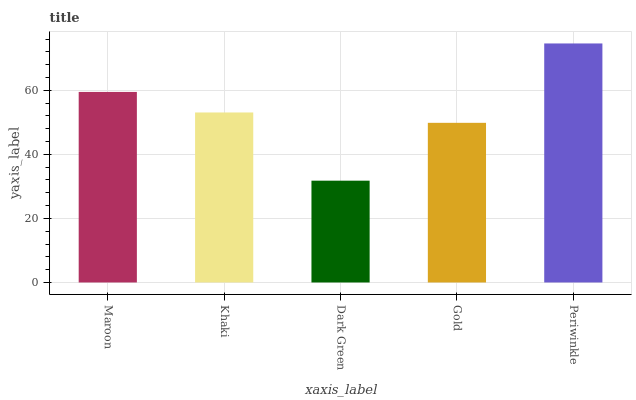Is Dark Green the minimum?
Answer yes or no. Yes. Is Periwinkle the maximum?
Answer yes or no. Yes. Is Khaki the minimum?
Answer yes or no. No. Is Khaki the maximum?
Answer yes or no. No. Is Maroon greater than Khaki?
Answer yes or no. Yes. Is Khaki less than Maroon?
Answer yes or no. Yes. Is Khaki greater than Maroon?
Answer yes or no. No. Is Maroon less than Khaki?
Answer yes or no. No. Is Khaki the high median?
Answer yes or no. Yes. Is Khaki the low median?
Answer yes or no. Yes. Is Maroon the high median?
Answer yes or no. No. Is Gold the low median?
Answer yes or no. No. 